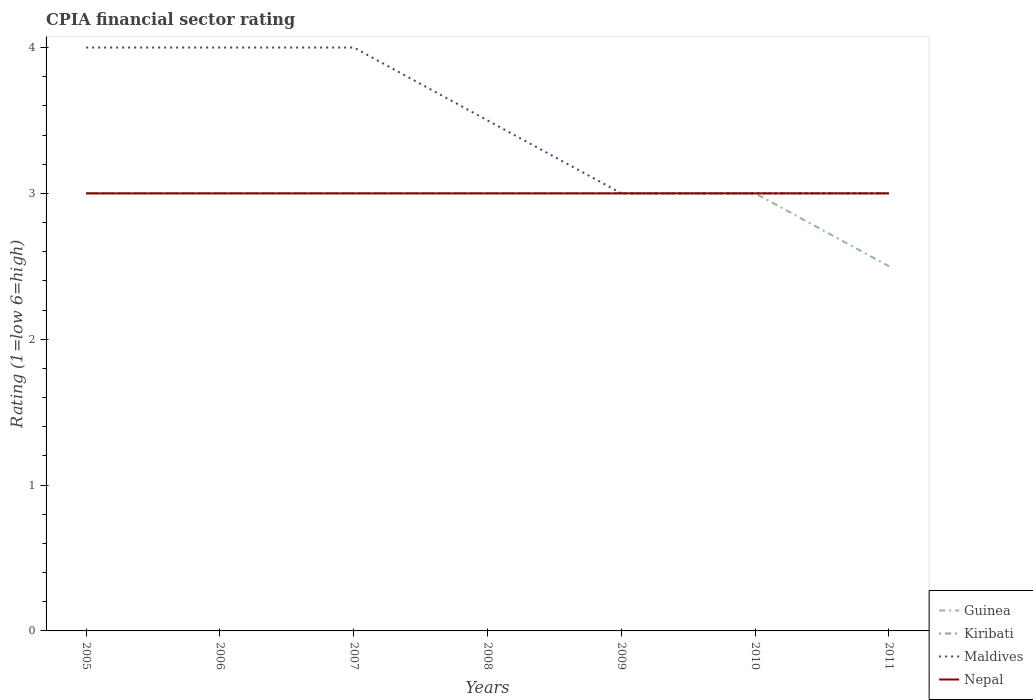How many different coloured lines are there?
Offer a terse response. 4. Is the number of lines equal to the number of legend labels?
Your answer should be compact. Yes. In which year was the CPIA rating in Nepal maximum?
Offer a terse response. 2005. What is the total CPIA rating in Nepal in the graph?
Provide a succinct answer. 0. What is the difference between the highest and the lowest CPIA rating in Guinea?
Provide a succinct answer. 6. How many lines are there?
Ensure brevity in your answer.  4. How many years are there in the graph?
Keep it short and to the point. 7. What is the difference between two consecutive major ticks on the Y-axis?
Your response must be concise. 1. Does the graph contain any zero values?
Your answer should be compact. No. How many legend labels are there?
Keep it short and to the point. 4. What is the title of the graph?
Your answer should be very brief. CPIA financial sector rating. What is the Rating (1=low 6=high) in Maldives in 2005?
Offer a very short reply. 4. What is the Rating (1=low 6=high) in Guinea in 2006?
Provide a short and direct response. 3. What is the Rating (1=low 6=high) of Kiribati in 2006?
Ensure brevity in your answer.  3. What is the Rating (1=low 6=high) of Maldives in 2006?
Offer a very short reply. 4. What is the Rating (1=low 6=high) in Guinea in 2007?
Give a very brief answer. 3. What is the Rating (1=low 6=high) in Kiribati in 2007?
Your answer should be very brief. 3. What is the Rating (1=low 6=high) of Nepal in 2007?
Offer a terse response. 3. What is the Rating (1=low 6=high) of Maldives in 2008?
Ensure brevity in your answer.  3.5. What is the Rating (1=low 6=high) of Guinea in 2009?
Offer a very short reply. 3. What is the Rating (1=low 6=high) in Kiribati in 2009?
Provide a short and direct response. 3. What is the Rating (1=low 6=high) in Nepal in 2009?
Your response must be concise. 3. What is the Rating (1=low 6=high) in Kiribati in 2010?
Your response must be concise. 3. Across all years, what is the maximum Rating (1=low 6=high) in Kiribati?
Offer a very short reply. 3. Across all years, what is the maximum Rating (1=low 6=high) of Maldives?
Keep it short and to the point. 4. Across all years, what is the maximum Rating (1=low 6=high) of Nepal?
Your answer should be very brief. 3. Across all years, what is the minimum Rating (1=low 6=high) of Guinea?
Your answer should be very brief. 2.5. What is the total Rating (1=low 6=high) of Nepal in the graph?
Your response must be concise. 21. What is the difference between the Rating (1=low 6=high) of Nepal in 2005 and that in 2006?
Provide a short and direct response. 0. What is the difference between the Rating (1=low 6=high) of Maldives in 2005 and that in 2008?
Offer a terse response. 0.5. What is the difference between the Rating (1=low 6=high) in Guinea in 2005 and that in 2009?
Offer a very short reply. 0. What is the difference between the Rating (1=low 6=high) in Maldives in 2005 and that in 2009?
Your response must be concise. 1. What is the difference between the Rating (1=low 6=high) in Kiribati in 2005 and that in 2010?
Ensure brevity in your answer.  0. What is the difference between the Rating (1=low 6=high) of Maldives in 2005 and that in 2010?
Offer a very short reply. 1. What is the difference between the Rating (1=low 6=high) in Guinea in 2005 and that in 2011?
Offer a very short reply. 0.5. What is the difference between the Rating (1=low 6=high) of Kiribati in 2005 and that in 2011?
Keep it short and to the point. 0. What is the difference between the Rating (1=low 6=high) of Nepal in 2005 and that in 2011?
Give a very brief answer. 0. What is the difference between the Rating (1=low 6=high) in Maldives in 2006 and that in 2007?
Your response must be concise. 0. What is the difference between the Rating (1=low 6=high) of Nepal in 2006 and that in 2007?
Make the answer very short. 0. What is the difference between the Rating (1=low 6=high) of Nepal in 2006 and that in 2010?
Ensure brevity in your answer.  0. What is the difference between the Rating (1=low 6=high) in Guinea in 2006 and that in 2011?
Offer a very short reply. 0.5. What is the difference between the Rating (1=low 6=high) in Kiribati in 2006 and that in 2011?
Ensure brevity in your answer.  0. What is the difference between the Rating (1=low 6=high) of Guinea in 2007 and that in 2008?
Provide a short and direct response. 0. What is the difference between the Rating (1=low 6=high) of Kiribati in 2007 and that in 2008?
Make the answer very short. 0. What is the difference between the Rating (1=low 6=high) of Nepal in 2007 and that in 2008?
Provide a short and direct response. 0. What is the difference between the Rating (1=low 6=high) of Guinea in 2007 and that in 2009?
Offer a terse response. 0. What is the difference between the Rating (1=low 6=high) of Kiribati in 2007 and that in 2009?
Offer a very short reply. 0. What is the difference between the Rating (1=low 6=high) in Nepal in 2007 and that in 2009?
Your response must be concise. 0. What is the difference between the Rating (1=low 6=high) of Nepal in 2007 and that in 2010?
Ensure brevity in your answer.  0. What is the difference between the Rating (1=low 6=high) in Guinea in 2007 and that in 2011?
Keep it short and to the point. 0.5. What is the difference between the Rating (1=low 6=high) of Nepal in 2007 and that in 2011?
Make the answer very short. 0. What is the difference between the Rating (1=low 6=high) of Kiribati in 2008 and that in 2009?
Your response must be concise. 0. What is the difference between the Rating (1=low 6=high) in Maldives in 2008 and that in 2009?
Offer a terse response. 0.5. What is the difference between the Rating (1=low 6=high) in Guinea in 2008 and that in 2010?
Ensure brevity in your answer.  0. What is the difference between the Rating (1=low 6=high) of Kiribati in 2008 and that in 2010?
Make the answer very short. 0. What is the difference between the Rating (1=low 6=high) in Kiribati in 2008 and that in 2011?
Provide a short and direct response. 0. What is the difference between the Rating (1=low 6=high) of Maldives in 2008 and that in 2011?
Offer a terse response. 0.5. What is the difference between the Rating (1=low 6=high) in Guinea in 2009 and that in 2010?
Your answer should be very brief. 0. What is the difference between the Rating (1=low 6=high) in Kiribati in 2009 and that in 2010?
Make the answer very short. 0. What is the difference between the Rating (1=low 6=high) in Guinea in 2009 and that in 2011?
Provide a succinct answer. 0.5. What is the difference between the Rating (1=low 6=high) in Nepal in 2009 and that in 2011?
Offer a very short reply. 0. What is the difference between the Rating (1=low 6=high) of Kiribati in 2010 and that in 2011?
Offer a very short reply. 0. What is the difference between the Rating (1=low 6=high) in Guinea in 2005 and the Rating (1=low 6=high) in Maldives in 2006?
Your answer should be compact. -1. What is the difference between the Rating (1=low 6=high) of Guinea in 2005 and the Rating (1=low 6=high) of Nepal in 2006?
Your response must be concise. 0. What is the difference between the Rating (1=low 6=high) in Kiribati in 2005 and the Rating (1=low 6=high) in Maldives in 2006?
Your answer should be very brief. -1. What is the difference between the Rating (1=low 6=high) in Kiribati in 2005 and the Rating (1=low 6=high) in Nepal in 2006?
Give a very brief answer. 0. What is the difference between the Rating (1=low 6=high) in Guinea in 2005 and the Rating (1=low 6=high) in Kiribati in 2007?
Provide a short and direct response. 0. What is the difference between the Rating (1=low 6=high) in Guinea in 2005 and the Rating (1=low 6=high) in Nepal in 2007?
Your answer should be compact. 0. What is the difference between the Rating (1=low 6=high) of Kiribati in 2005 and the Rating (1=low 6=high) of Maldives in 2007?
Ensure brevity in your answer.  -1. What is the difference between the Rating (1=low 6=high) of Kiribati in 2005 and the Rating (1=low 6=high) of Nepal in 2007?
Make the answer very short. 0. What is the difference between the Rating (1=low 6=high) of Guinea in 2005 and the Rating (1=low 6=high) of Kiribati in 2008?
Provide a short and direct response. 0. What is the difference between the Rating (1=low 6=high) of Guinea in 2005 and the Rating (1=low 6=high) of Maldives in 2008?
Give a very brief answer. -0.5. What is the difference between the Rating (1=low 6=high) of Maldives in 2005 and the Rating (1=low 6=high) of Nepal in 2008?
Your answer should be very brief. 1. What is the difference between the Rating (1=low 6=high) in Guinea in 2005 and the Rating (1=low 6=high) in Kiribati in 2009?
Make the answer very short. 0. What is the difference between the Rating (1=low 6=high) of Guinea in 2005 and the Rating (1=low 6=high) of Kiribati in 2010?
Keep it short and to the point. 0. What is the difference between the Rating (1=low 6=high) of Guinea in 2005 and the Rating (1=low 6=high) of Maldives in 2010?
Provide a short and direct response. 0. What is the difference between the Rating (1=low 6=high) of Kiribati in 2005 and the Rating (1=low 6=high) of Maldives in 2010?
Offer a terse response. 0. What is the difference between the Rating (1=low 6=high) in Guinea in 2005 and the Rating (1=low 6=high) in Maldives in 2011?
Keep it short and to the point. 0. What is the difference between the Rating (1=low 6=high) in Guinea in 2005 and the Rating (1=low 6=high) in Nepal in 2011?
Ensure brevity in your answer.  0. What is the difference between the Rating (1=low 6=high) of Maldives in 2005 and the Rating (1=low 6=high) of Nepal in 2011?
Keep it short and to the point. 1. What is the difference between the Rating (1=low 6=high) of Maldives in 2006 and the Rating (1=low 6=high) of Nepal in 2007?
Offer a terse response. 1. What is the difference between the Rating (1=low 6=high) in Guinea in 2006 and the Rating (1=low 6=high) in Maldives in 2008?
Your answer should be compact. -0.5. What is the difference between the Rating (1=low 6=high) of Guinea in 2006 and the Rating (1=low 6=high) of Nepal in 2008?
Make the answer very short. 0. What is the difference between the Rating (1=low 6=high) in Kiribati in 2006 and the Rating (1=low 6=high) in Maldives in 2008?
Offer a very short reply. -0.5. What is the difference between the Rating (1=low 6=high) of Maldives in 2006 and the Rating (1=low 6=high) of Nepal in 2008?
Ensure brevity in your answer.  1. What is the difference between the Rating (1=low 6=high) of Guinea in 2006 and the Rating (1=low 6=high) of Nepal in 2009?
Keep it short and to the point. 0. What is the difference between the Rating (1=low 6=high) in Kiribati in 2006 and the Rating (1=low 6=high) in Nepal in 2009?
Offer a very short reply. 0. What is the difference between the Rating (1=low 6=high) of Guinea in 2006 and the Rating (1=low 6=high) of Kiribati in 2010?
Your answer should be compact. 0. What is the difference between the Rating (1=low 6=high) of Guinea in 2006 and the Rating (1=low 6=high) of Maldives in 2010?
Your answer should be very brief. 0. What is the difference between the Rating (1=low 6=high) of Kiribati in 2006 and the Rating (1=low 6=high) of Maldives in 2010?
Provide a succinct answer. 0. What is the difference between the Rating (1=low 6=high) in Kiribati in 2006 and the Rating (1=low 6=high) in Nepal in 2010?
Ensure brevity in your answer.  0. What is the difference between the Rating (1=low 6=high) of Maldives in 2006 and the Rating (1=low 6=high) of Nepal in 2010?
Provide a short and direct response. 1. What is the difference between the Rating (1=low 6=high) of Guinea in 2006 and the Rating (1=low 6=high) of Nepal in 2011?
Offer a very short reply. 0. What is the difference between the Rating (1=low 6=high) of Kiribati in 2006 and the Rating (1=low 6=high) of Nepal in 2011?
Ensure brevity in your answer.  0. What is the difference between the Rating (1=low 6=high) in Maldives in 2006 and the Rating (1=low 6=high) in Nepal in 2011?
Keep it short and to the point. 1. What is the difference between the Rating (1=low 6=high) of Guinea in 2007 and the Rating (1=low 6=high) of Kiribati in 2008?
Give a very brief answer. 0. What is the difference between the Rating (1=low 6=high) of Guinea in 2007 and the Rating (1=low 6=high) of Maldives in 2008?
Keep it short and to the point. -0.5. What is the difference between the Rating (1=low 6=high) in Kiribati in 2007 and the Rating (1=low 6=high) in Maldives in 2008?
Offer a very short reply. -0.5. What is the difference between the Rating (1=low 6=high) in Maldives in 2007 and the Rating (1=low 6=high) in Nepal in 2008?
Ensure brevity in your answer.  1. What is the difference between the Rating (1=low 6=high) in Guinea in 2007 and the Rating (1=low 6=high) in Nepal in 2009?
Offer a very short reply. 0. What is the difference between the Rating (1=low 6=high) of Kiribati in 2007 and the Rating (1=low 6=high) of Maldives in 2009?
Offer a terse response. 0. What is the difference between the Rating (1=low 6=high) in Kiribati in 2007 and the Rating (1=low 6=high) in Nepal in 2009?
Your response must be concise. 0. What is the difference between the Rating (1=low 6=high) in Guinea in 2007 and the Rating (1=low 6=high) in Maldives in 2010?
Your answer should be compact. 0. What is the difference between the Rating (1=low 6=high) of Guinea in 2007 and the Rating (1=low 6=high) of Maldives in 2011?
Your answer should be very brief. 0. What is the difference between the Rating (1=low 6=high) in Kiribati in 2007 and the Rating (1=low 6=high) in Maldives in 2011?
Your response must be concise. 0. What is the difference between the Rating (1=low 6=high) of Kiribati in 2007 and the Rating (1=low 6=high) of Nepal in 2011?
Offer a terse response. 0. What is the difference between the Rating (1=low 6=high) in Maldives in 2007 and the Rating (1=low 6=high) in Nepal in 2011?
Give a very brief answer. 1. What is the difference between the Rating (1=low 6=high) of Guinea in 2008 and the Rating (1=low 6=high) of Nepal in 2009?
Make the answer very short. 0. What is the difference between the Rating (1=low 6=high) in Maldives in 2008 and the Rating (1=low 6=high) in Nepal in 2009?
Keep it short and to the point. 0.5. What is the difference between the Rating (1=low 6=high) of Guinea in 2008 and the Rating (1=low 6=high) of Maldives in 2010?
Your answer should be compact. 0. What is the difference between the Rating (1=low 6=high) in Guinea in 2008 and the Rating (1=low 6=high) in Nepal in 2010?
Your response must be concise. 0. What is the difference between the Rating (1=low 6=high) in Kiribati in 2008 and the Rating (1=low 6=high) in Maldives in 2010?
Ensure brevity in your answer.  0. What is the difference between the Rating (1=low 6=high) in Guinea in 2008 and the Rating (1=low 6=high) in Maldives in 2011?
Your answer should be compact. 0. What is the difference between the Rating (1=low 6=high) of Kiribati in 2008 and the Rating (1=low 6=high) of Maldives in 2011?
Your answer should be very brief. 0. What is the difference between the Rating (1=low 6=high) of Kiribati in 2008 and the Rating (1=low 6=high) of Nepal in 2011?
Your answer should be very brief. 0. What is the difference between the Rating (1=low 6=high) in Guinea in 2009 and the Rating (1=low 6=high) in Kiribati in 2010?
Provide a short and direct response. 0. What is the difference between the Rating (1=low 6=high) of Guinea in 2009 and the Rating (1=low 6=high) of Maldives in 2010?
Your response must be concise. 0. What is the difference between the Rating (1=low 6=high) in Guinea in 2009 and the Rating (1=low 6=high) in Nepal in 2010?
Provide a succinct answer. 0. What is the difference between the Rating (1=low 6=high) of Maldives in 2009 and the Rating (1=low 6=high) of Nepal in 2010?
Your response must be concise. 0. What is the difference between the Rating (1=low 6=high) of Guinea in 2009 and the Rating (1=low 6=high) of Maldives in 2011?
Offer a terse response. 0. What is the difference between the Rating (1=low 6=high) of Guinea in 2009 and the Rating (1=low 6=high) of Nepal in 2011?
Give a very brief answer. 0. What is the difference between the Rating (1=low 6=high) in Guinea in 2010 and the Rating (1=low 6=high) in Kiribati in 2011?
Offer a terse response. 0. What is the difference between the Rating (1=low 6=high) in Guinea in 2010 and the Rating (1=low 6=high) in Maldives in 2011?
Make the answer very short. 0. What is the difference between the Rating (1=low 6=high) of Guinea in 2010 and the Rating (1=low 6=high) of Nepal in 2011?
Your response must be concise. 0. What is the difference between the Rating (1=low 6=high) of Maldives in 2010 and the Rating (1=low 6=high) of Nepal in 2011?
Your answer should be compact. 0. What is the average Rating (1=low 6=high) in Guinea per year?
Your answer should be compact. 2.93. What is the average Rating (1=low 6=high) in Kiribati per year?
Make the answer very short. 3. What is the average Rating (1=low 6=high) of Maldives per year?
Ensure brevity in your answer.  3.5. What is the average Rating (1=low 6=high) in Nepal per year?
Provide a succinct answer. 3. In the year 2005, what is the difference between the Rating (1=low 6=high) of Kiribati and Rating (1=low 6=high) of Maldives?
Ensure brevity in your answer.  -1. In the year 2005, what is the difference between the Rating (1=low 6=high) in Maldives and Rating (1=low 6=high) in Nepal?
Make the answer very short. 1. In the year 2006, what is the difference between the Rating (1=low 6=high) of Guinea and Rating (1=low 6=high) of Kiribati?
Your response must be concise. 0. In the year 2006, what is the difference between the Rating (1=low 6=high) of Guinea and Rating (1=low 6=high) of Maldives?
Ensure brevity in your answer.  -1. In the year 2006, what is the difference between the Rating (1=low 6=high) of Kiribati and Rating (1=low 6=high) of Maldives?
Make the answer very short. -1. In the year 2006, what is the difference between the Rating (1=low 6=high) in Maldives and Rating (1=low 6=high) in Nepal?
Keep it short and to the point. 1. In the year 2007, what is the difference between the Rating (1=low 6=high) in Guinea and Rating (1=low 6=high) in Maldives?
Offer a terse response. -1. In the year 2007, what is the difference between the Rating (1=low 6=high) in Guinea and Rating (1=low 6=high) in Nepal?
Give a very brief answer. 0. In the year 2007, what is the difference between the Rating (1=low 6=high) in Kiribati and Rating (1=low 6=high) in Maldives?
Offer a terse response. -1. In the year 2007, what is the difference between the Rating (1=low 6=high) in Kiribati and Rating (1=low 6=high) in Nepal?
Your response must be concise. 0. In the year 2008, what is the difference between the Rating (1=low 6=high) in Guinea and Rating (1=low 6=high) in Maldives?
Your answer should be compact. -0.5. In the year 2008, what is the difference between the Rating (1=low 6=high) of Kiribati and Rating (1=low 6=high) of Maldives?
Your answer should be compact. -0.5. In the year 2009, what is the difference between the Rating (1=low 6=high) in Guinea and Rating (1=low 6=high) in Kiribati?
Ensure brevity in your answer.  0. In the year 2009, what is the difference between the Rating (1=low 6=high) of Guinea and Rating (1=low 6=high) of Nepal?
Your response must be concise. 0. In the year 2009, what is the difference between the Rating (1=low 6=high) in Kiribati and Rating (1=low 6=high) in Nepal?
Provide a succinct answer. 0. In the year 2009, what is the difference between the Rating (1=low 6=high) in Maldives and Rating (1=low 6=high) in Nepal?
Your response must be concise. 0. In the year 2010, what is the difference between the Rating (1=low 6=high) of Guinea and Rating (1=low 6=high) of Kiribati?
Give a very brief answer. 0. In the year 2010, what is the difference between the Rating (1=low 6=high) in Guinea and Rating (1=low 6=high) in Nepal?
Your answer should be compact. 0. In the year 2010, what is the difference between the Rating (1=low 6=high) in Kiribati and Rating (1=low 6=high) in Maldives?
Your answer should be compact. 0. In the year 2010, what is the difference between the Rating (1=low 6=high) in Maldives and Rating (1=low 6=high) in Nepal?
Your answer should be very brief. 0. In the year 2011, what is the difference between the Rating (1=low 6=high) in Guinea and Rating (1=low 6=high) in Kiribati?
Provide a short and direct response. -0.5. In the year 2011, what is the difference between the Rating (1=low 6=high) of Guinea and Rating (1=low 6=high) of Maldives?
Your answer should be very brief. -0.5. In the year 2011, what is the difference between the Rating (1=low 6=high) of Guinea and Rating (1=low 6=high) of Nepal?
Your answer should be very brief. -0.5. In the year 2011, what is the difference between the Rating (1=low 6=high) of Kiribati and Rating (1=low 6=high) of Maldives?
Provide a succinct answer. 0. In the year 2011, what is the difference between the Rating (1=low 6=high) of Kiribati and Rating (1=low 6=high) of Nepal?
Your response must be concise. 0. In the year 2011, what is the difference between the Rating (1=low 6=high) of Maldives and Rating (1=low 6=high) of Nepal?
Offer a terse response. 0. What is the ratio of the Rating (1=low 6=high) of Maldives in 2005 to that in 2006?
Make the answer very short. 1. What is the ratio of the Rating (1=low 6=high) in Maldives in 2005 to that in 2008?
Offer a very short reply. 1.14. What is the ratio of the Rating (1=low 6=high) of Guinea in 2005 to that in 2009?
Ensure brevity in your answer.  1. What is the ratio of the Rating (1=low 6=high) in Kiribati in 2005 to that in 2009?
Give a very brief answer. 1. What is the ratio of the Rating (1=low 6=high) in Maldives in 2005 to that in 2009?
Ensure brevity in your answer.  1.33. What is the ratio of the Rating (1=low 6=high) of Nepal in 2005 to that in 2009?
Make the answer very short. 1. What is the ratio of the Rating (1=low 6=high) of Guinea in 2005 to that in 2011?
Offer a very short reply. 1.2. What is the ratio of the Rating (1=low 6=high) of Maldives in 2005 to that in 2011?
Make the answer very short. 1.33. What is the ratio of the Rating (1=low 6=high) of Kiribati in 2006 to that in 2007?
Ensure brevity in your answer.  1. What is the ratio of the Rating (1=low 6=high) of Nepal in 2006 to that in 2007?
Your response must be concise. 1. What is the ratio of the Rating (1=low 6=high) in Guinea in 2006 to that in 2008?
Keep it short and to the point. 1. What is the ratio of the Rating (1=low 6=high) of Kiribati in 2006 to that in 2008?
Keep it short and to the point. 1. What is the ratio of the Rating (1=low 6=high) of Maldives in 2006 to that in 2008?
Your answer should be compact. 1.14. What is the ratio of the Rating (1=low 6=high) of Guinea in 2006 to that in 2010?
Provide a short and direct response. 1. What is the ratio of the Rating (1=low 6=high) in Kiribati in 2006 to that in 2010?
Keep it short and to the point. 1. What is the ratio of the Rating (1=low 6=high) of Guinea in 2006 to that in 2011?
Your answer should be very brief. 1.2. What is the ratio of the Rating (1=low 6=high) of Kiribati in 2006 to that in 2011?
Provide a short and direct response. 1. What is the ratio of the Rating (1=low 6=high) of Maldives in 2006 to that in 2011?
Make the answer very short. 1.33. What is the ratio of the Rating (1=low 6=high) in Kiribati in 2007 to that in 2008?
Your response must be concise. 1. What is the ratio of the Rating (1=low 6=high) in Maldives in 2007 to that in 2008?
Offer a very short reply. 1.14. What is the ratio of the Rating (1=low 6=high) in Nepal in 2007 to that in 2008?
Offer a terse response. 1. What is the ratio of the Rating (1=low 6=high) of Maldives in 2007 to that in 2009?
Give a very brief answer. 1.33. What is the ratio of the Rating (1=low 6=high) of Nepal in 2007 to that in 2009?
Offer a very short reply. 1. What is the ratio of the Rating (1=low 6=high) of Kiribati in 2007 to that in 2010?
Ensure brevity in your answer.  1. What is the ratio of the Rating (1=low 6=high) in Nepal in 2007 to that in 2010?
Provide a short and direct response. 1. What is the ratio of the Rating (1=low 6=high) in Kiribati in 2007 to that in 2011?
Provide a succinct answer. 1. What is the ratio of the Rating (1=low 6=high) of Maldives in 2007 to that in 2011?
Make the answer very short. 1.33. What is the ratio of the Rating (1=low 6=high) in Nepal in 2007 to that in 2011?
Offer a terse response. 1. What is the ratio of the Rating (1=low 6=high) in Guinea in 2008 to that in 2009?
Offer a very short reply. 1. What is the ratio of the Rating (1=low 6=high) of Nepal in 2008 to that in 2009?
Give a very brief answer. 1. What is the ratio of the Rating (1=low 6=high) of Nepal in 2008 to that in 2010?
Your response must be concise. 1. What is the ratio of the Rating (1=low 6=high) of Guinea in 2008 to that in 2011?
Make the answer very short. 1.2. What is the ratio of the Rating (1=low 6=high) of Kiribati in 2008 to that in 2011?
Make the answer very short. 1. What is the ratio of the Rating (1=low 6=high) of Maldives in 2008 to that in 2011?
Keep it short and to the point. 1.17. What is the ratio of the Rating (1=low 6=high) of Nepal in 2008 to that in 2011?
Offer a terse response. 1. What is the ratio of the Rating (1=low 6=high) in Guinea in 2009 to that in 2010?
Your answer should be very brief. 1. What is the ratio of the Rating (1=low 6=high) in Nepal in 2009 to that in 2010?
Offer a very short reply. 1. What is the ratio of the Rating (1=low 6=high) of Guinea in 2009 to that in 2011?
Provide a short and direct response. 1.2. What is the ratio of the Rating (1=low 6=high) in Kiribati in 2009 to that in 2011?
Keep it short and to the point. 1. What is the ratio of the Rating (1=low 6=high) in Maldives in 2009 to that in 2011?
Provide a short and direct response. 1. What is the ratio of the Rating (1=low 6=high) in Nepal in 2009 to that in 2011?
Your answer should be compact. 1. What is the ratio of the Rating (1=low 6=high) of Guinea in 2010 to that in 2011?
Offer a very short reply. 1.2. What is the ratio of the Rating (1=low 6=high) of Kiribati in 2010 to that in 2011?
Your answer should be very brief. 1. What is the ratio of the Rating (1=low 6=high) in Maldives in 2010 to that in 2011?
Your answer should be compact. 1. What is the ratio of the Rating (1=low 6=high) of Nepal in 2010 to that in 2011?
Provide a short and direct response. 1. What is the difference between the highest and the lowest Rating (1=low 6=high) in Guinea?
Make the answer very short. 0.5. What is the difference between the highest and the lowest Rating (1=low 6=high) of Kiribati?
Keep it short and to the point. 0. What is the difference between the highest and the lowest Rating (1=low 6=high) of Nepal?
Ensure brevity in your answer.  0. 